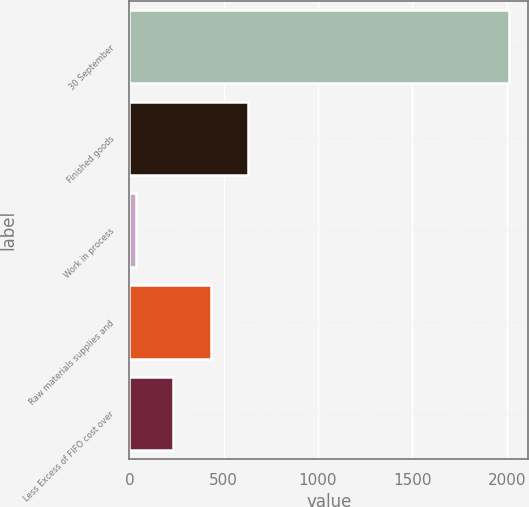<chart> <loc_0><loc_0><loc_500><loc_500><bar_chart><fcel>30 September<fcel>Finished goods<fcel>Work in process<fcel>Raw materials supplies and<fcel>Less Excess of FIFO cost over<nl><fcel>2014<fcel>628.07<fcel>34.1<fcel>430.08<fcel>232.09<nl></chart> 